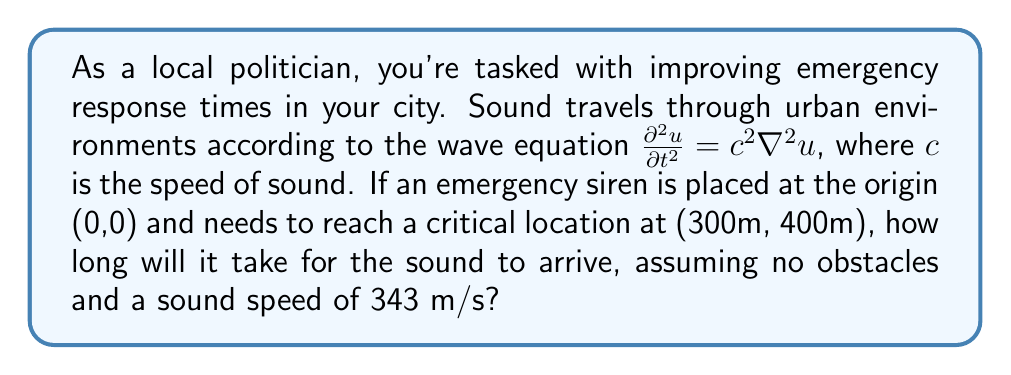Can you solve this math problem? To solve this problem, we'll follow these steps:

1) The wave equation describes how sound propagates, but for this simple case, we only need to calculate the time for sound to travel in a straight line from the origin to the critical location.

2) We can find the distance using the Pythagorean theorem:

   $$d = \sqrt{x^2 + y^2}$$
   
   where $x = 300$ m and $y = 400$ m.

3) Plugging in the values:

   $$d = \sqrt{300^2 + 400^2} = \sqrt{90,000 + 160,000} = \sqrt{250,000} = 500 \text{ m}$$

4) Now that we have the distance, we can use the simple equation:

   $$t = \frac{d}{c}$$

   where $t$ is time, $d$ is distance, and $c$ is the speed of sound.

5) Plugging in our values:

   $$t = \frac{500 \text{ m}}{343 \text{ m/s}} \approx 1.4577 \text{ s}$$

6) Rounding to two decimal places for practicality in emergency response planning:

   $$t \approx 1.46 \text{ s}$$
Answer: 1.46 seconds 